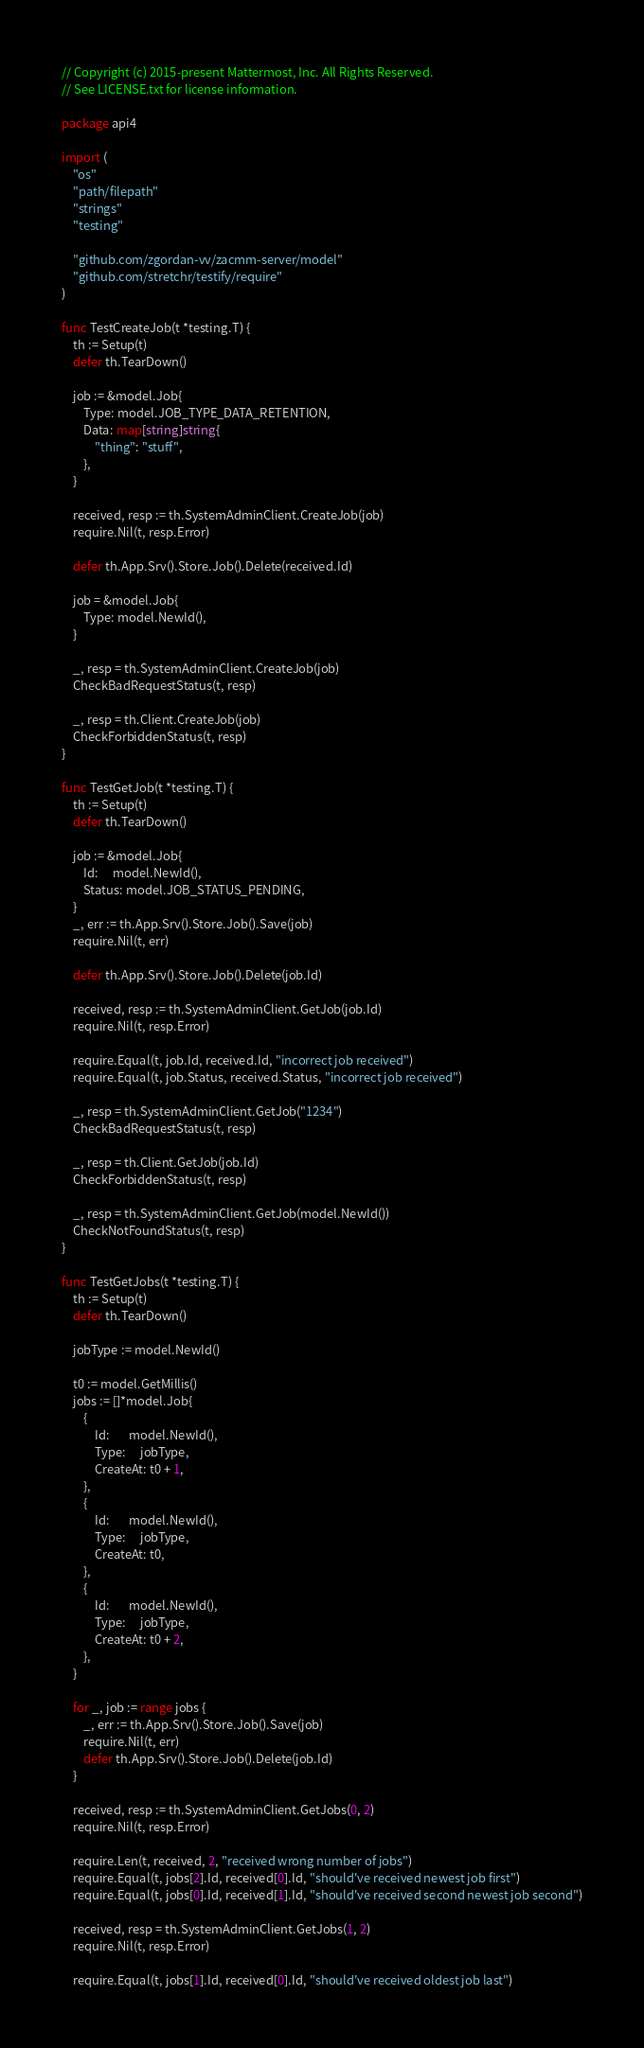<code> <loc_0><loc_0><loc_500><loc_500><_Go_>// Copyright (c) 2015-present Mattermost, Inc. All Rights Reserved.
// See LICENSE.txt for license information.

package api4

import (
	"os"
	"path/filepath"
	"strings"
	"testing"

	"github.com/zgordan-vv/zacmm-server/model"
	"github.com/stretchr/testify/require"
)

func TestCreateJob(t *testing.T) {
	th := Setup(t)
	defer th.TearDown()

	job := &model.Job{
		Type: model.JOB_TYPE_DATA_RETENTION,
		Data: map[string]string{
			"thing": "stuff",
		},
	}

	received, resp := th.SystemAdminClient.CreateJob(job)
	require.Nil(t, resp.Error)

	defer th.App.Srv().Store.Job().Delete(received.Id)

	job = &model.Job{
		Type: model.NewId(),
	}

	_, resp = th.SystemAdminClient.CreateJob(job)
	CheckBadRequestStatus(t, resp)

	_, resp = th.Client.CreateJob(job)
	CheckForbiddenStatus(t, resp)
}

func TestGetJob(t *testing.T) {
	th := Setup(t)
	defer th.TearDown()

	job := &model.Job{
		Id:     model.NewId(),
		Status: model.JOB_STATUS_PENDING,
	}
	_, err := th.App.Srv().Store.Job().Save(job)
	require.Nil(t, err)

	defer th.App.Srv().Store.Job().Delete(job.Id)

	received, resp := th.SystemAdminClient.GetJob(job.Id)
	require.Nil(t, resp.Error)

	require.Equal(t, job.Id, received.Id, "incorrect job received")
	require.Equal(t, job.Status, received.Status, "incorrect job received")

	_, resp = th.SystemAdminClient.GetJob("1234")
	CheckBadRequestStatus(t, resp)

	_, resp = th.Client.GetJob(job.Id)
	CheckForbiddenStatus(t, resp)

	_, resp = th.SystemAdminClient.GetJob(model.NewId())
	CheckNotFoundStatus(t, resp)
}

func TestGetJobs(t *testing.T) {
	th := Setup(t)
	defer th.TearDown()

	jobType := model.NewId()

	t0 := model.GetMillis()
	jobs := []*model.Job{
		{
			Id:       model.NewId(),
			Type:     jobType,
			CreateAt: t0 + 1,
		},
		{
			Id:       model.NewId(),
			Type:     jobType,
			CreateAt: t0,
		},
		{
			Id:       model.NewId(),
			Type:     jobType,
			CreateAt: t0 + 2,
		},
	}

	for _, job := range jobs {
		_, err := th.App.Srv().Store.Job().Save(job)
		require.Nil(t, err)
		defer th.App.Srv().Store.Job().Delete(job.Id)
	}

	received, resp := th.SystemAdminClient.GetJobs(0, 2)
	require.Nil(t, resp.Error)

	require.Len(t, received, 2, "received wrong number of jobs")
	require.Equal(t, jobs[2].Id, received[0].Id, "should've received newest job first")
	require.Equal(t, jobs[0].Id, received[1].Id, "should've received second newest job second")

	received, resp = th.SystemAdminClient.GetJobs(1, 2)
	require.Nil(t, resp.Error)

	require.Equal(t, jobs[1].Id, received[0].Id, "should've received oldest job last")
</code> 